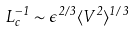<formula> <loc_0><loc_0><loc_500><loc_500>L _ { c } ^ { - 1 } \sim \epsilon ^ { 2 / 3 } \langle V ^ { 2 } \rangle ^ { 1 / 3 }</formula> 